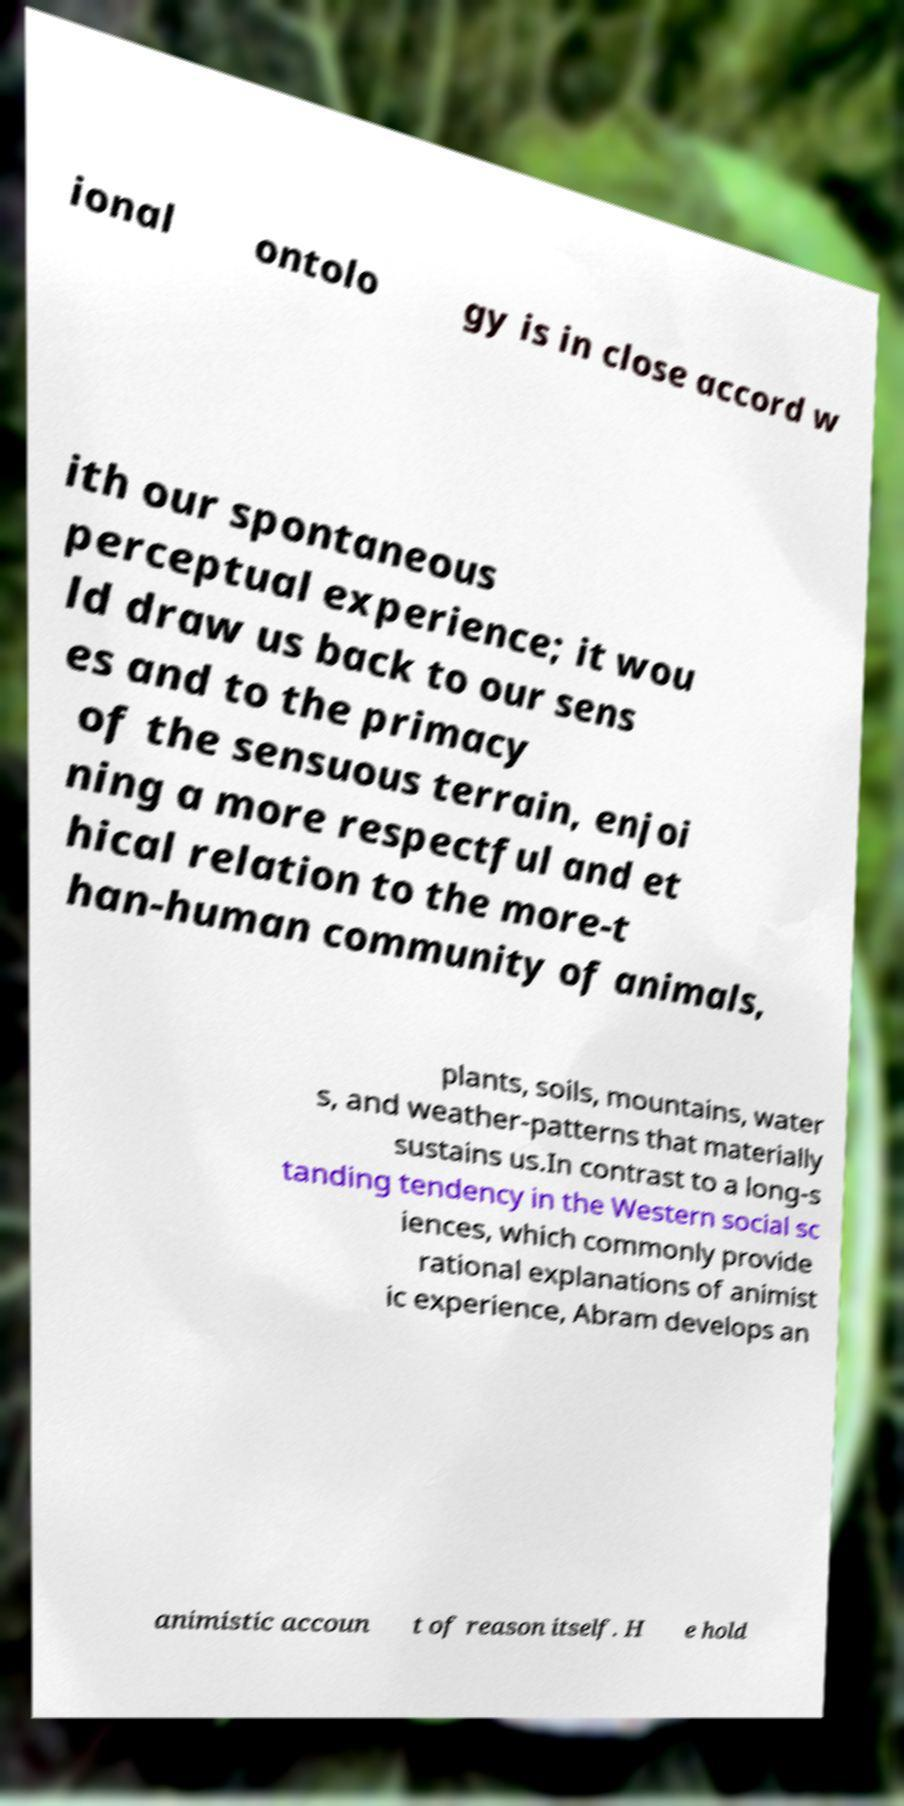What messages or text are displayed in this image? I need them in a readable, typed format. ional ontolo gy is in close accord w ith our spontaneous perceptual experience; it wou ld draw us back to our sens es and to the primacy of the sensuous terrain, enjoi ning a more respectful and et hical relation to the more-t han-human community of animals, plants, soils, mountains, water s, and weather-patterns that materially sustains us.In contrast to a long-s tanding tendency in the Western social sc iences, which commonly provide rational explanations of animist ic experience, Abram develops an animistic accoun t of reason itself. H e hold 